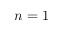<formula> <loc_0><loc_0><loc_500><loc_500>n = 1</formula> 